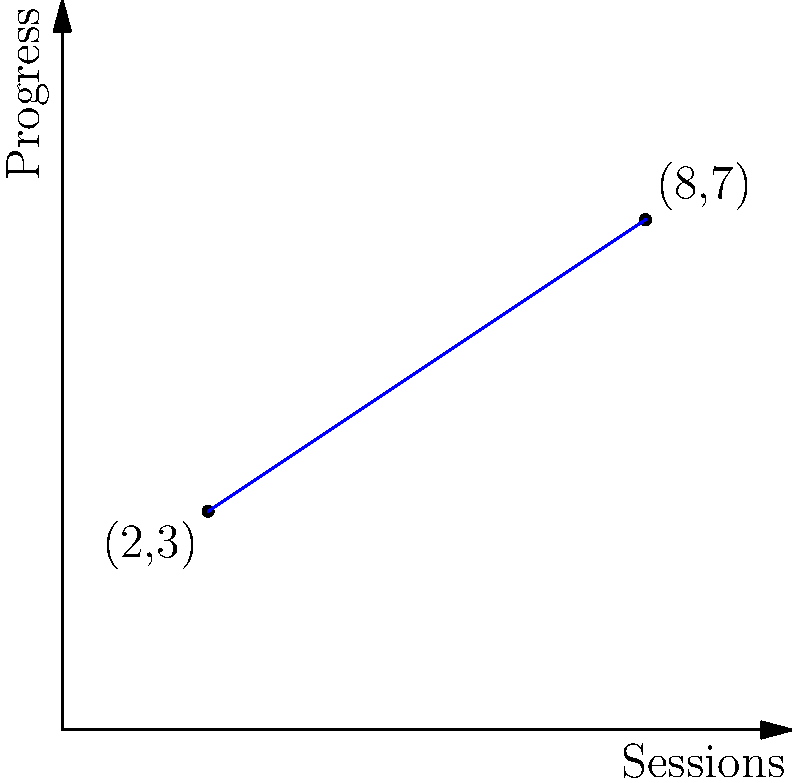In the graph above, two points represent the progress made during therapy sessions. The x-axis shows the number of sessions, and the y-axis represents the progress score. Calculate the slope of the line connecting these two points, which illustrates the rate of progress in therapy. What does this slope indicate about the patient's improvement over time? To calculate the slope of the line connecting two points, we use the formula:

$$ \text{Slope} = \frac{y_2 - y_1}{x_2 - x_1} $$

Where $(x_1, y_1)$ is the first point and $(x_2, y_2)$ is the second point.

From the graph, we can see:
$(x_1, y_1) = (2, 3)$ and $(x_2, y_2) = (8, 7)$

Let's substitute these values into the formula:

$$ \text{Slope} = \frac{7 - 3}{8 - 2} = \frac{4}{6} = \frac{2}{3} \approx 0.67 $$

The slope is positive, indicating that progress is increasing over time. Specifically, for every additional therapy session, the progress score increases by approximately 0.67 units.

This slope indicates a steady improvement in the patient's condition over the course of therapy. It suggests that the therapy sessions are effective, as there is a consistent positive change in the progress score as more sessions are completed.
Answer: $\frac{2}{3}$ or 0.67; indicates steady improvement 